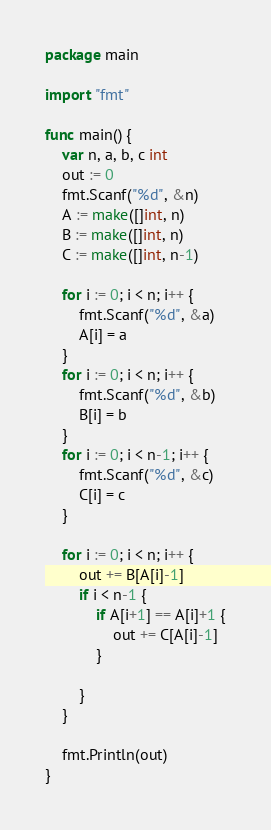<code> <loc_0><loc_0><loc_500><loc_500><_Go_>package main

import "fmt"

func main() {
	var n, a, b, c int
	out := 0
	fmt.Scanf("%d", &n)
	A := make([]int, n)
	B := make([]int, n)
	C := make([]int, n-1)

	for i := 0; i < n; i++ {
		fmt.Scanf("%d", &a)
		A[i] = a
	}
	for i := 0; i < n; i++ {
		fmt.Scanf("%d", &b)
		B[i] = b
	}
	for i := 0; i < n-1; i++ {
		fmt.Scanf("%d", &c)
		C[i] = c
	}

	for i := 0; i < n; i++ {
		out += B[A[i]-1]
		if i < n-1 {
			if A[i+1] == A[i]+1 {
				out += C[A[i]-1]
			}

		}
	}

	fmt.Println(out)
}
</code> 